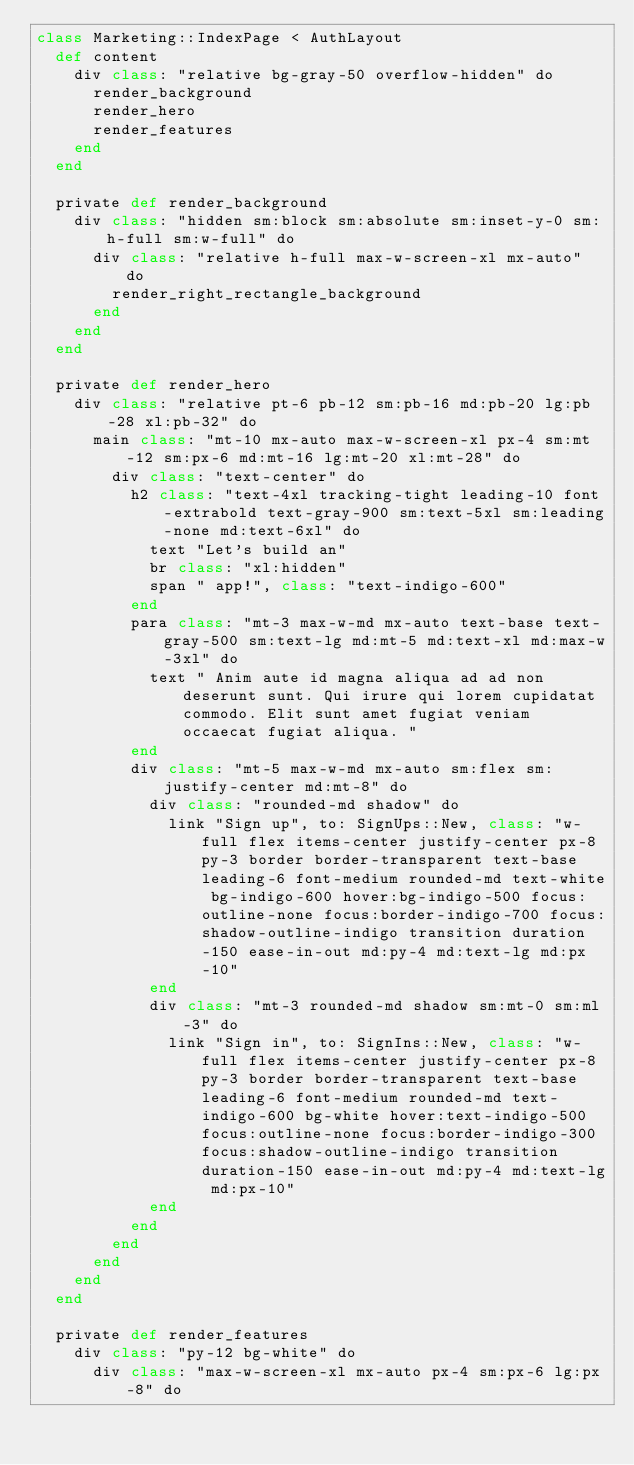<code> <loc_0><loc_0><loc_500><loc_500><_Crystal_>class Marketing::IndexPage < AuthLayout
  def content
    div class: "relative bg-gray-50 overflow-hidden" do
      render_background
      render_hero
      render_features
    end
  end

  private def render_background
    div class: "hidden sm:block sm:absolute sm:inset-y-0 sm:h-full sm:w-full" do
      div class: "relative h-full max-w-screen-xl mx-auto" do
        render_right_rectangle_background
      end
    end
  end

  private def render_hero
    div class: "relative pt-6 pb-12 sm:pb-16 md:pb-20 lg:pb-28 xl:pb-32" do
      main class: "mt-10 mx-auto max-w-screen-xl px-4 sm:mt-12 sm:px-6 md:mt-16 lg:mt-20 xl:mt-28" do
        div class: "text-center" do
          h2 class: "text-4xl tracking-tight leading-10 font-extrabold text-gray-900 sm:text-5xl sm:leading-none md:text-6xl" do
            text "Let's build an"
            br class: "xl:hidden"
            span " app!", class: "text-indigo-600"
          end
          para class: "mt-3 max-w-md mx-auto text-base text-gray-500 sm:text-lg md:mt-5 md:text-xl md:max-w-3xl" do
            text " Anim aute id magna aliqua ad ad non deserunt sunt. Qui irure qui lorem cupidatat commodo. Elit sunt amet fugiat veniam occaecat fugiat aliqua. "
          end
          div class: "mt-5 max-w-md mx-auto sm:flex sm:justify-center md:mt-8" do
            div class: "rounded-md shadow" do
              link "Sign up", to: SignUps::New, class: "w-full flex items-center justify-center px-8 py-3 border border-transparent text-base leading-6 font-medium rounded-md text-white bg-indigo-600 hover:bg-indigo-500 focus:outline-none focus:border-indigo-700 focus:shadow-outline-indigo transition duration-150 ease-in-out md:py-4 md:text-lg md:px-10"
            end
            div class: "mt-3 rounded-md shadow sm:mt-0 sm:ml-3" do
              link "Sign in", to: SignIns::New, class: "w-full flex items-center justify-center px-8 py-3 border border-transparent text-base leading-6 font-medium rounded-md text-indigo-600 bg-white hover:text-indigo-500 focus:outline-none focus:border-indigo-300 focus:shadow-outline-indigo transition duration-150 ease-in-out md:py-4 md:text-lg md:px-10"
            end
          end
        end
      end
    end
  end

  private def render_features
    div class: "py-12 bg-white" do
      div class: "max-w-screen-xl mx-auto px-4 sm:px-6 lg:px-8" do</code> 